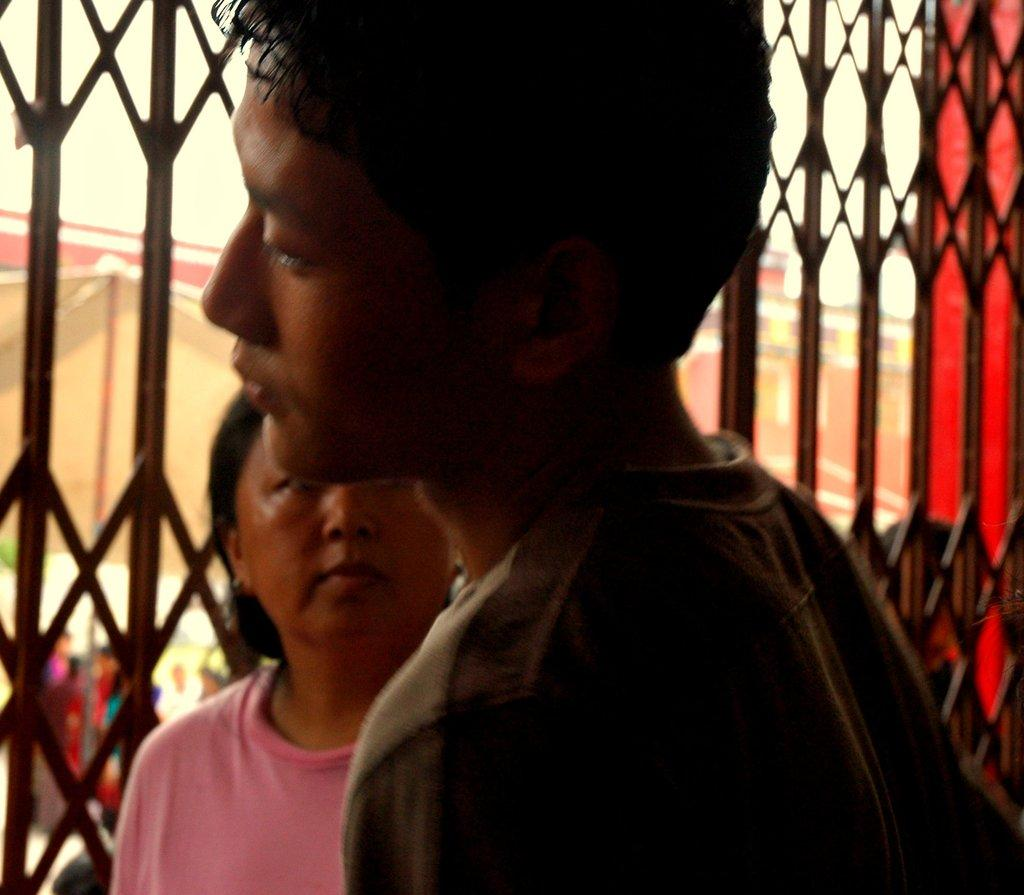Who is the main subject in the image? There is a boy in the center of the image. Can you describe the woman in the image? There is a woman behind the boy in the image. What can be seen in the background of the image? There is a gate in the background of the image. How many amusement parks can be seen in the image? There are no amusement parks visible in the image. What color are the eyes of the boy in the image? The provided facts do not mention the color of the boy's eyes, so we cannot determine that information from the image. 